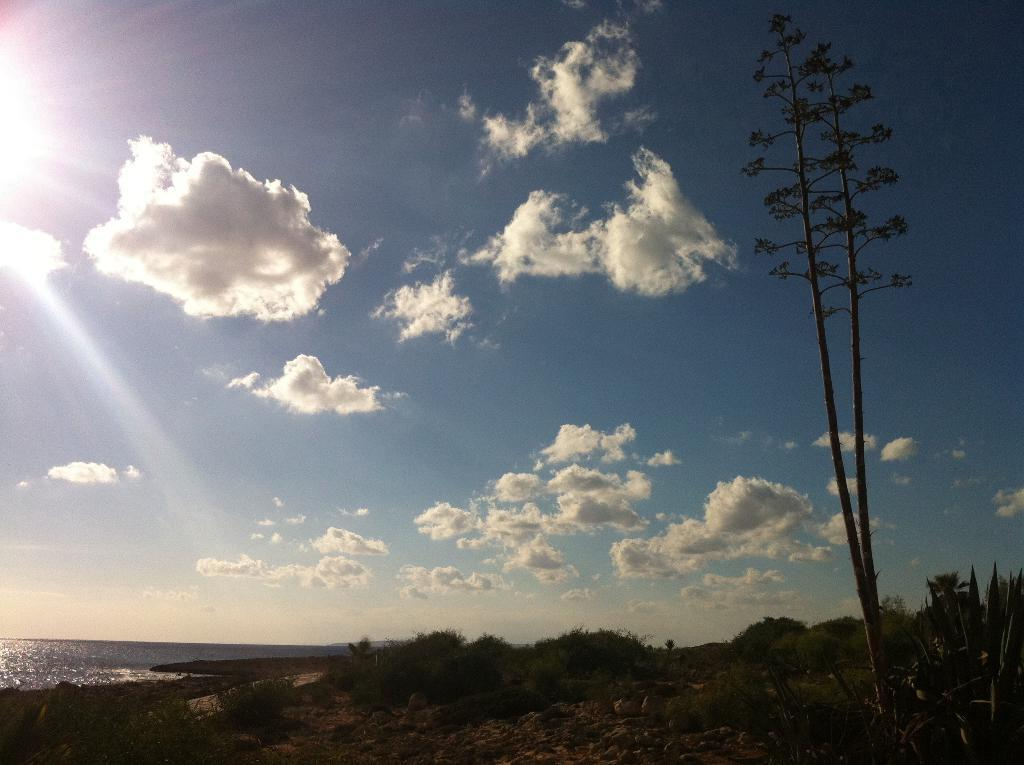What type of location is depicted in the image? There is a beach in the image. What can be seen on the mud at the beach? There are plants and a tree on the mud in the image. What is visible in the sky in the image? The sky is visible in the image, and there are clouds in the sky. What type of bean is being grown in the image? There are no beans present in the image; it features a beach with plants, a tree, and clouds in the sky. 